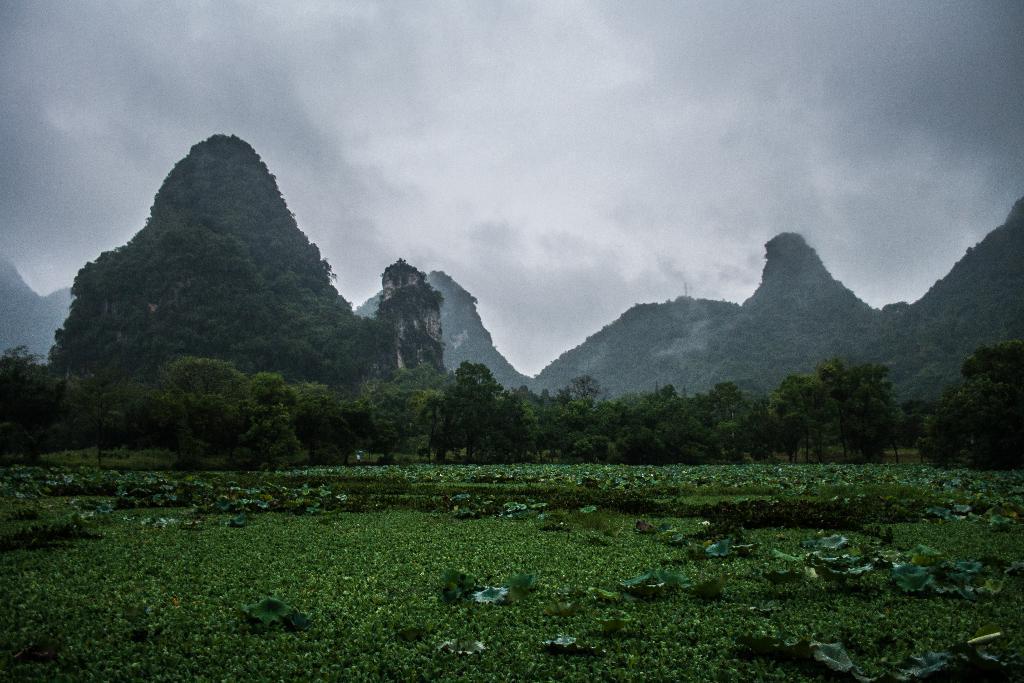How would you summarize this image in a sentence or two? In this image we can see a group of plants, leaves, a group of trees, the mountains and the sky which looks cloudy. 